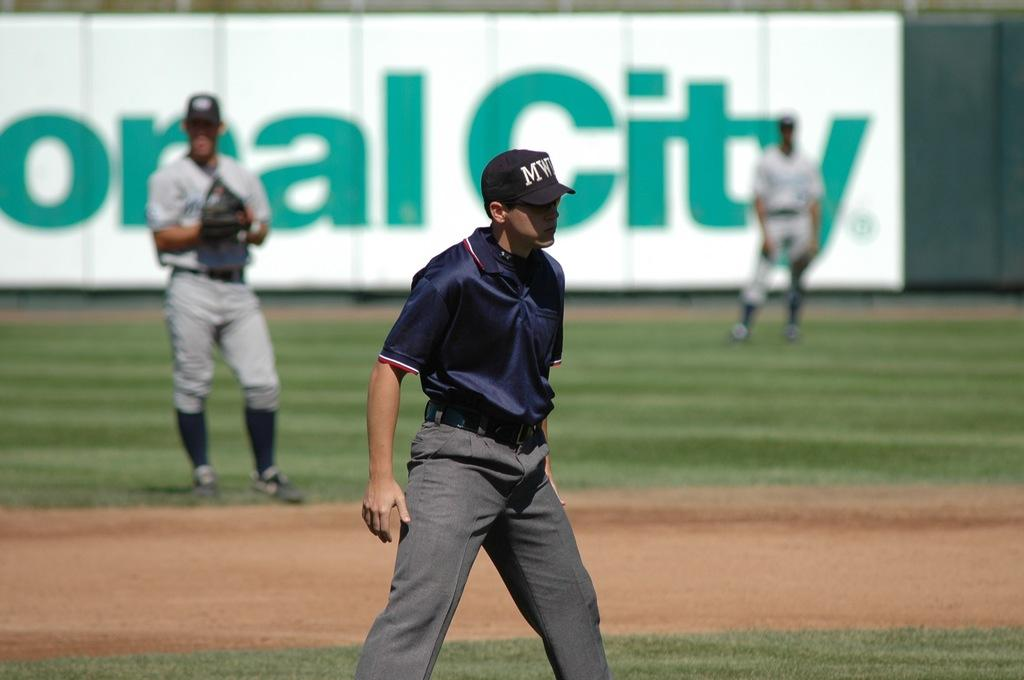<image>
Provide a brief description of the given image. An ump has a hat on with a logo that starts with the letter M. 